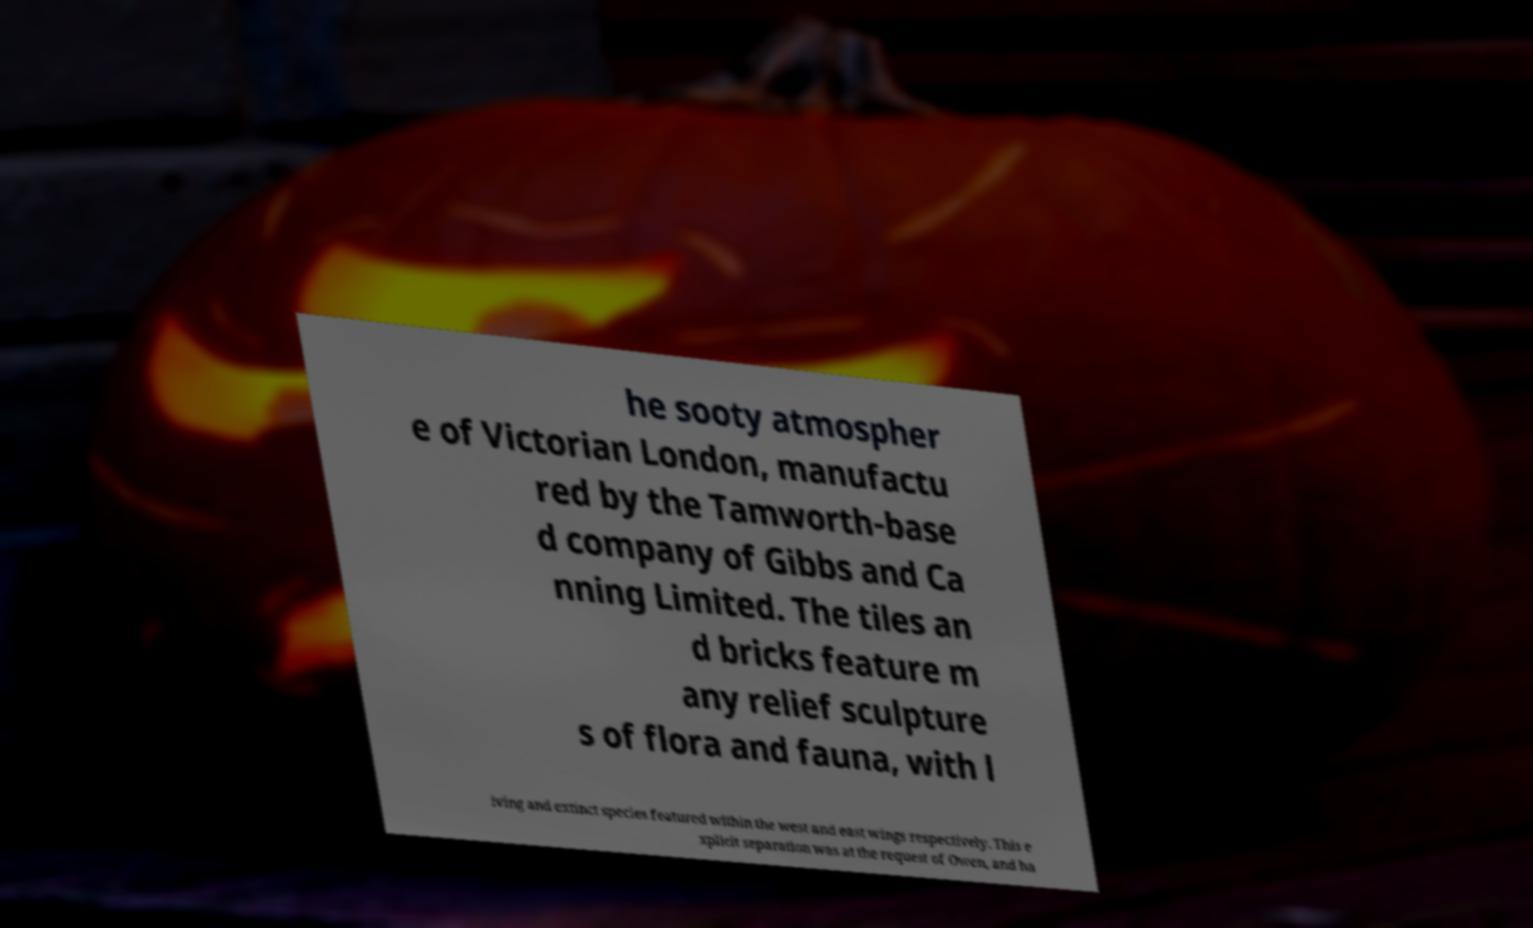Can you read and provide the text displayed in the image?This photo seems to have some interesting text. Can you extract and type it out for me? he sooty atmospher e of Victorian London, manufactu red by the Tamworth-base d company of Gibbs and Ca nning Limited. The tiles an d bricks feature m any relief sculpture s of flora and fauna, with l iving and extinct species featured within the west and east wings respectively. This e xplicit separation was at the request of Owen, and ha 